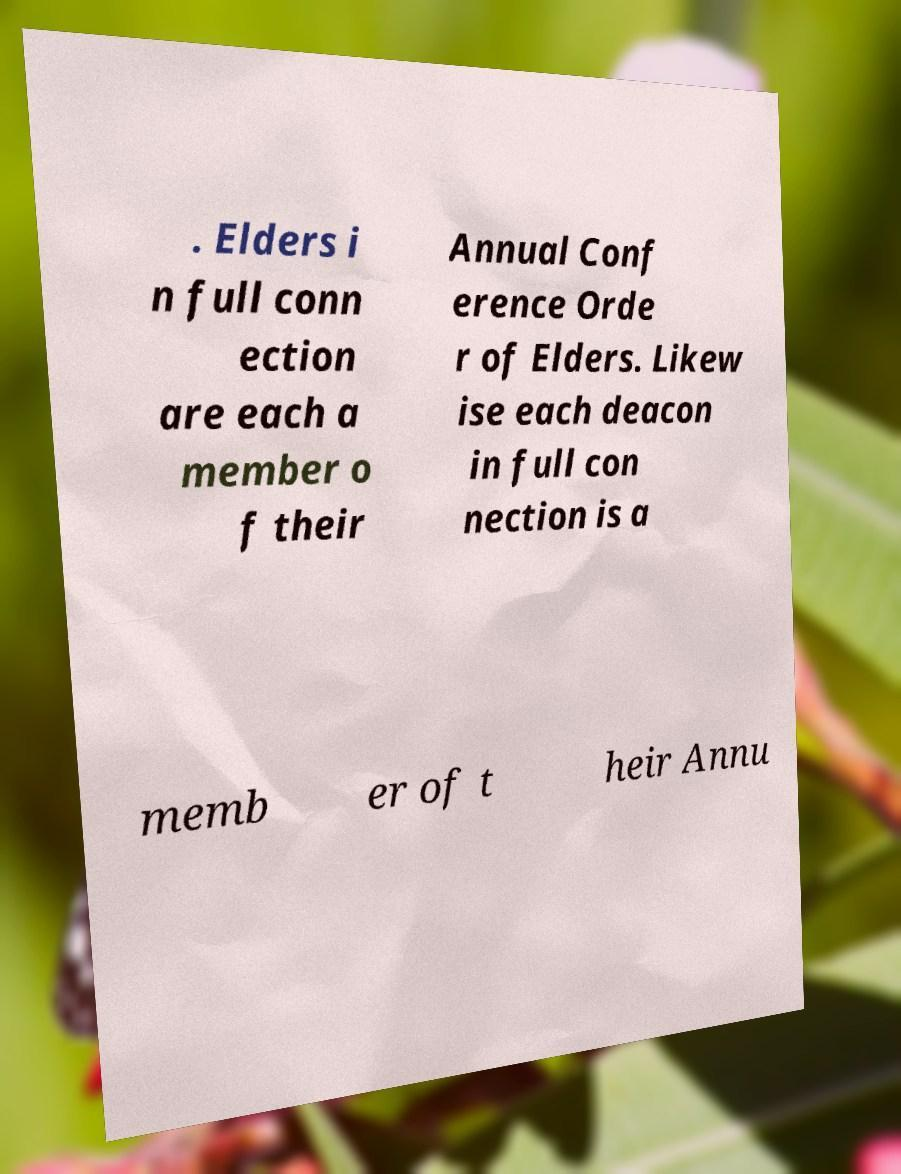Please read and relay the text visible in this image. What does it say? . Elders i n full conn ection are each a member o f their Annual Conf erence Orde r of Elders. Likew ise each deacon in full con nection is a memb er of t heir Annu 